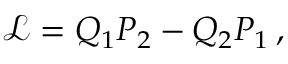<formula> <loc_0><loc_0><loc_500><loc_500>\begin{array} { r } { { \mathcal { L } } = Q _ { 1 } P _ { 2 } - Q _ { 2 } P _ { 1 } \, , } \end{array}</formula> 